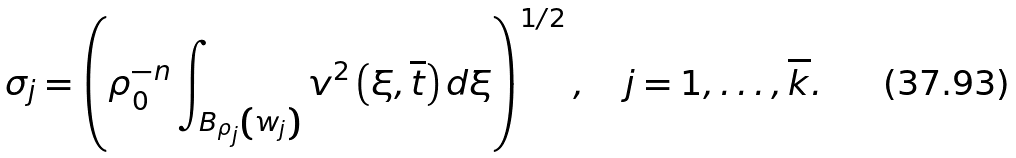Convert formula to latex. <formula><loc_0><loc_0><loc_500><loc_500>\sigma _ { j } = \left ( \rho _ { 0 } ^ { - n } \int \nolimits _ { B _ { \rho _ { j } } \left ( w _ { j } \right ) } v ^ { 2 } \left ( \xi , \overline { t } \right ) d \xi \right ) ^ { 1 / 2 } , \quad j = 1 , \dots , \overline { k } .</formula> 